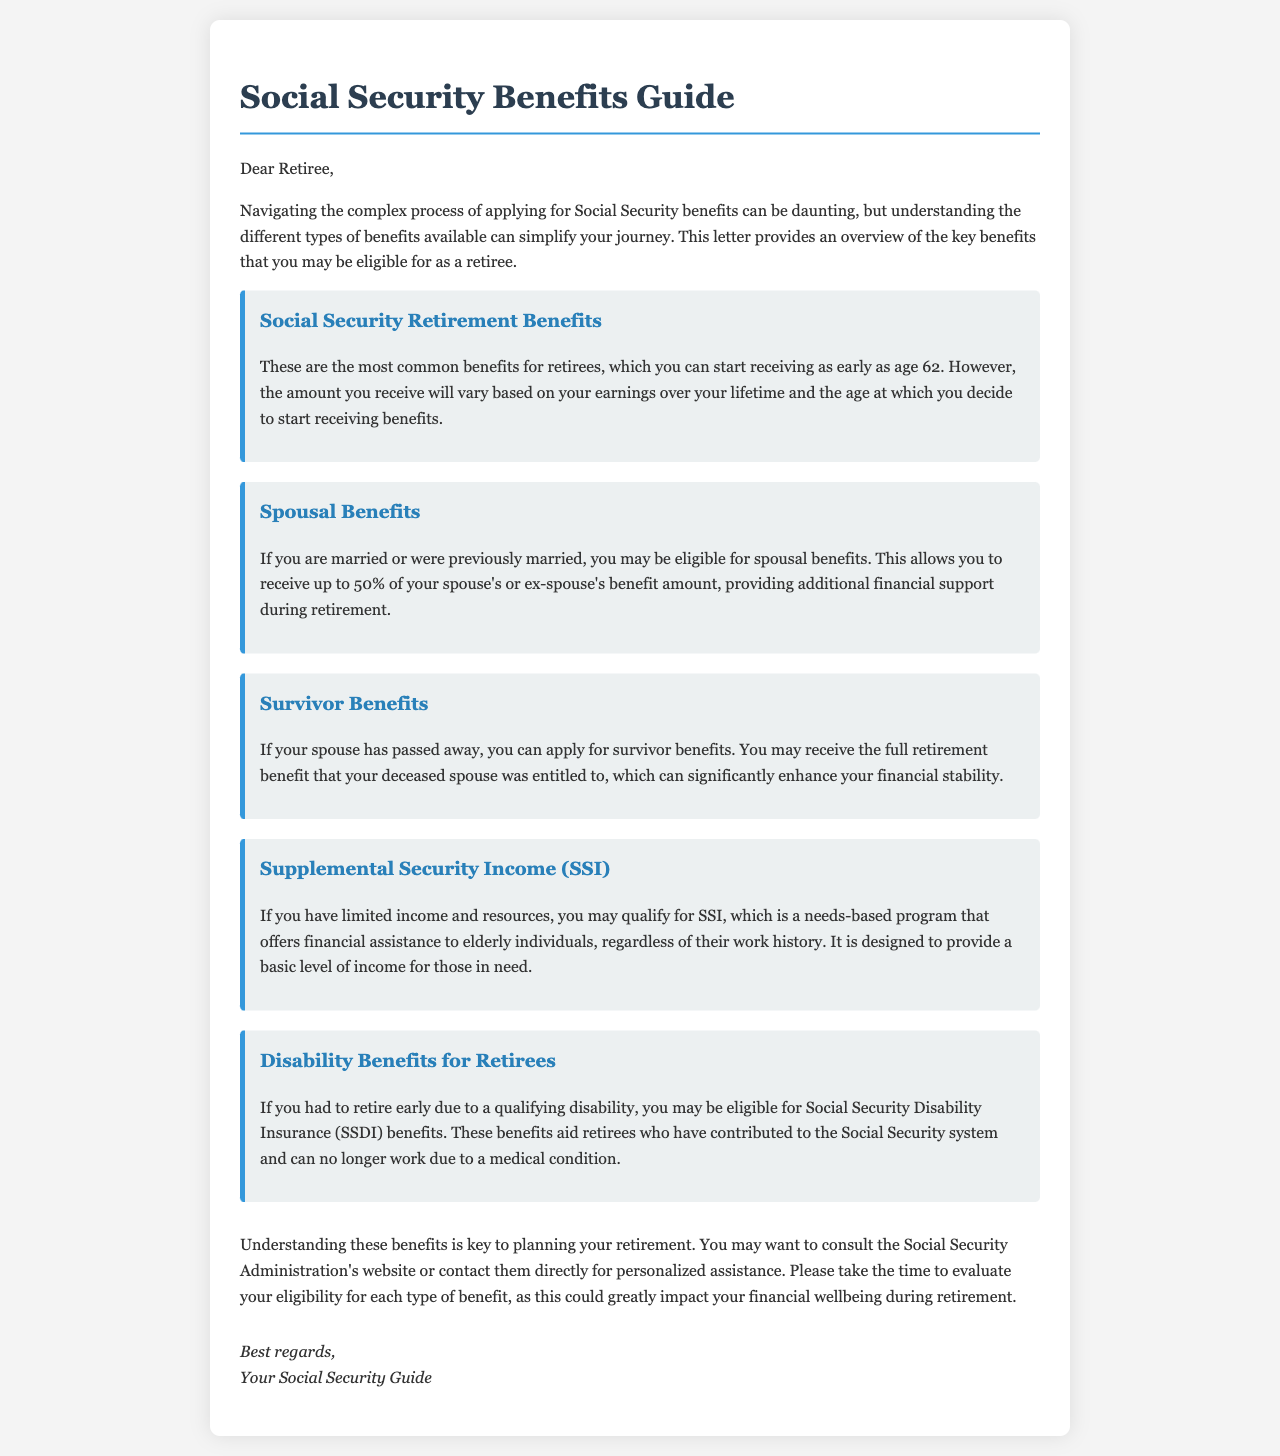What is the title of the document? The title is the headline that informs readers about the content covered in the document.
Answer: Social Security Benefits Guide At what age can you start receiving Social Security Retirement Benefits? The document states the minimum age at which retirees can begin to receive these benefits.
Answer: 62 What percentage of a spouse's benefit can one receive as spousal benefits? The document specifies the maximum amount that can be received from a spouse's benefit as spousal benefits.
Answer: 50% What kind of benefits can you receive if your spouse has passed away? This refers to additional financial support available to individuals after losing a spouse, as mentioned in the document.
Answer: Survivor Benefits What financial assistance is provided by Supplemental Security Income (SSI)? The document describes the financial assistance aspects of a specific program available for individuals with limited income.
Answer: Needs-based program Which benefits are available for retirees who had to retire early due to a disability? This question addresses a specific benefit type for retirees facing medical conditions.
Answer: Disability Benefits for Retirees Why is it important to understand these benefits? The document emphasizes a specific reason why retirees should be aware of these benefits.
Answer: Planning your retirement What should you do if you need personalized assistance regarding Social Security benefits? This question touches on the suggested actions for individuals seeking more information.
Answer: Consult the Social Security Administration's website or contact them directly 